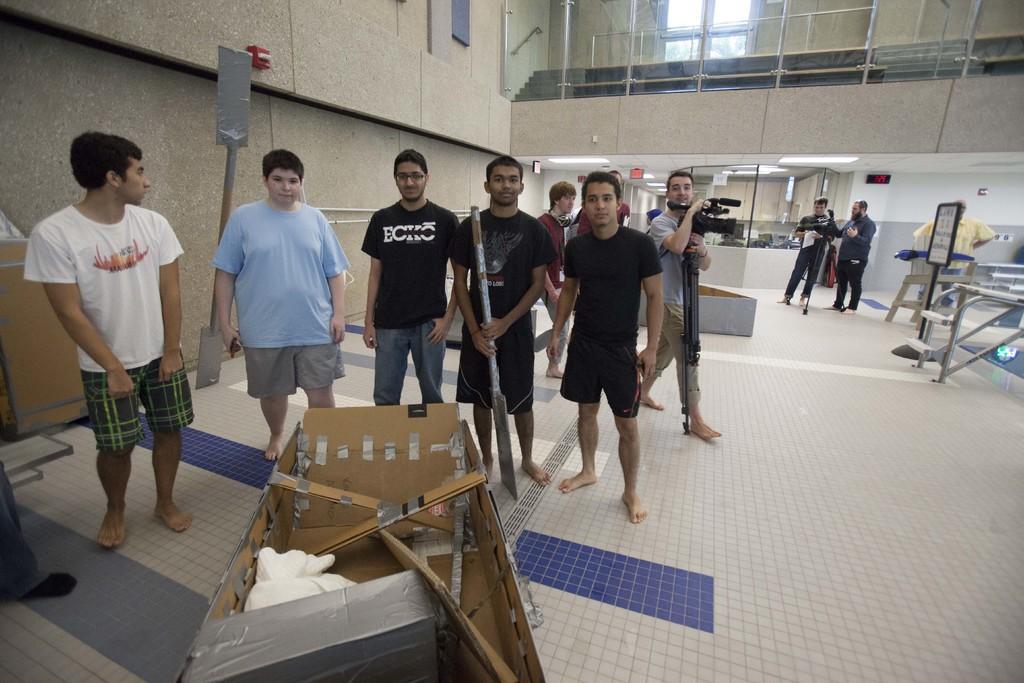Could you give a brief overview of what you see in this image? Inside an organisation a group of people are standing in a hall,few of them are posing for the photo and behind the people another person is working by holding a camera in his hand,in front of the people there is an object made up of cardboard and in the background there are windows made up of glasses and beside the glasses there is a wall. 